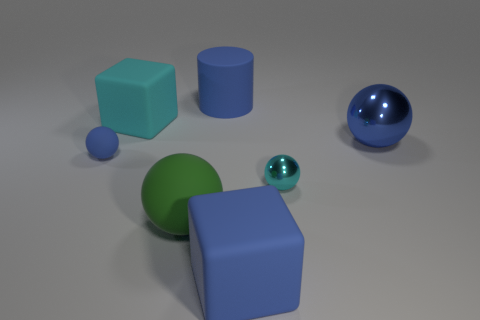Subtract all green blocks. How many blue balls are left? 2 Subtract all cyan balls. How many balls are left? 3 Subtract 2 balls. How many balls are left? 2 Subtract all large green matte balls. How many balls are left? 3 Add 2 large green balls. How many objects exist? 9 Subtract all purple spheres. Subtract all red cylinders. How many spheres are left? 4 Subtract all cylinders. How many objects are left? 6 Add 5 large blue blocks. How many large blue blocks are left? 6 Add 1 large blue things. How many large blue things exist? 4 Subtract 0 yellow balls. How many objects are left? 7 